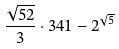Convert formula to latex. <formula><loc_0><loc_0><loc_500><loc_500>\frac { \sqrt { 5 2 } } { 3 } \cdot 3 4 1 - 2 ^ { \sqrt { 5 } }</formula> 